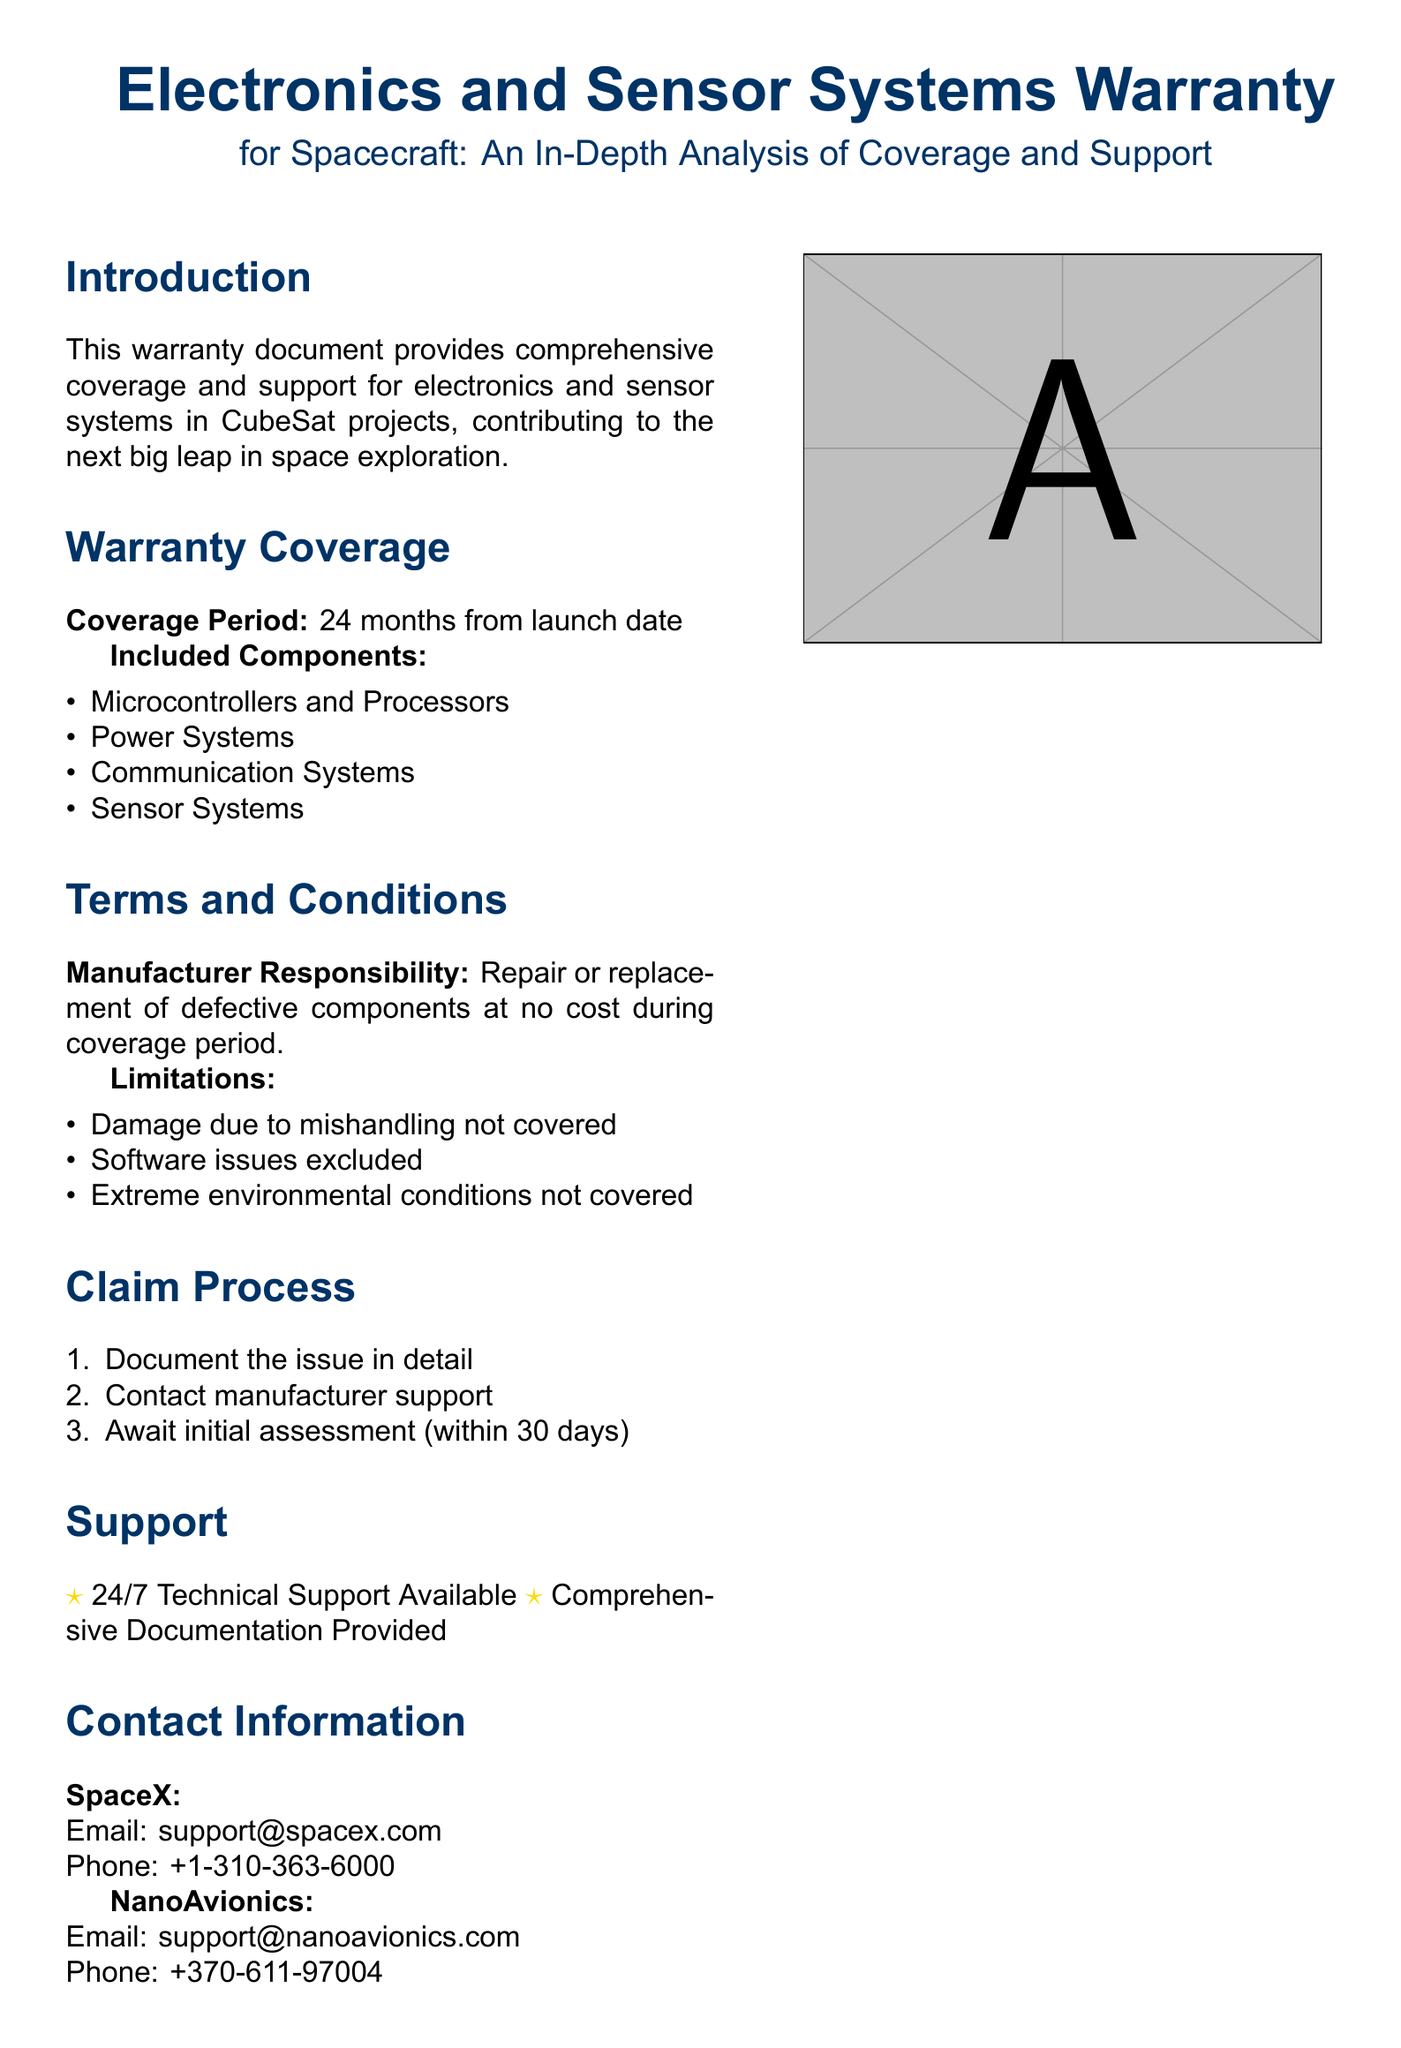What is the coverage period of the warranty? The coverage period is stated in the document as 24 months from the launch date.
Answer: 24 months Which components are included in the warranty? The document lists the components covered by the warranty, such as Microcontrollers, Power Systems, Communication Systems, and Sensor Systems.
Answer: Microcontrollers and Processors, Power Systems, Communication Systems, Sensor Systems What is the manufacturer responsible for during the coverage period? The document indicates that the manufacturer is responsible for the repair or replacement of defective components at no cost during the coverage period.
Answer: Repair or replacement of defective components What is excluded from the warranty coverage? The document specifies exclusions, such as damage due to mishandling, software issues, and extreme environmental conditions.
Answer: Damage due to mishandling How long does the claimant have to wait for an initial assessment? According to the document, a claimant should await the initial assessment within 30 days after reporting the issue.
Answer: 30 days Is technical support available? The document mentions that 24/7 Technical Support is available, indicating that support is always accessible.
Answer: 24/7 Technical Support Available What is the contact email for SpaceX? The document lists the contact email for SpaceX support as support@spacex.com.
Answer: support@spacex.com What must a claimant do first in the claim process? The document specifies that the first step in the claim process is to document the issue in detail.
Answer: Document the issue in detail 